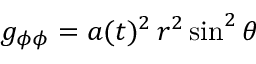Convert formula to latex. <formula><loc_0><loc_0><loc_500><loc_500>g _ { \phi \phi } = a ( t ) ^ { 2 } \, r ^ { 2 } \sin ^ { 2 } \theta</formula> 